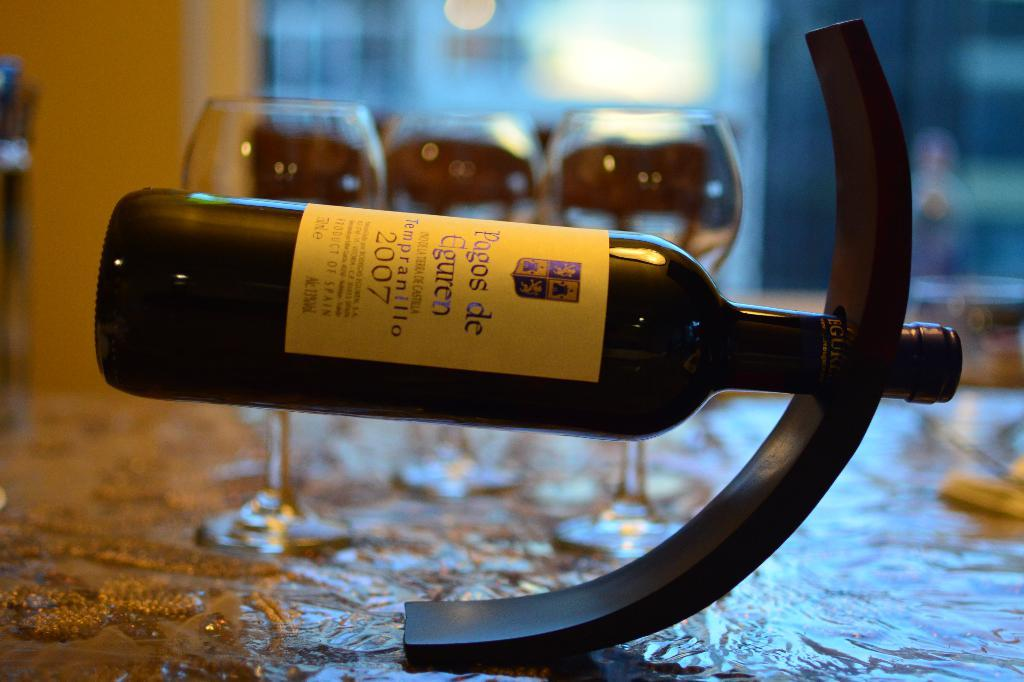Provide a one-sentence caption for the provided image. A bottle of 2007 wine is displayed horizontally on a table. 